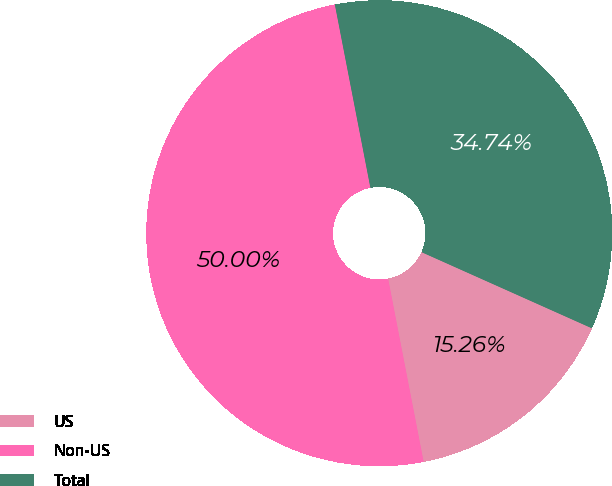Convert chart. <chart><loc_0><loc_0><loc_500><loc_500><pie_chart><fcel>US<fcel>Non-US<fcel>Total<nl><fcel>15.26%<fcel>50.0%<fcel>34.74%<nl></chart> 